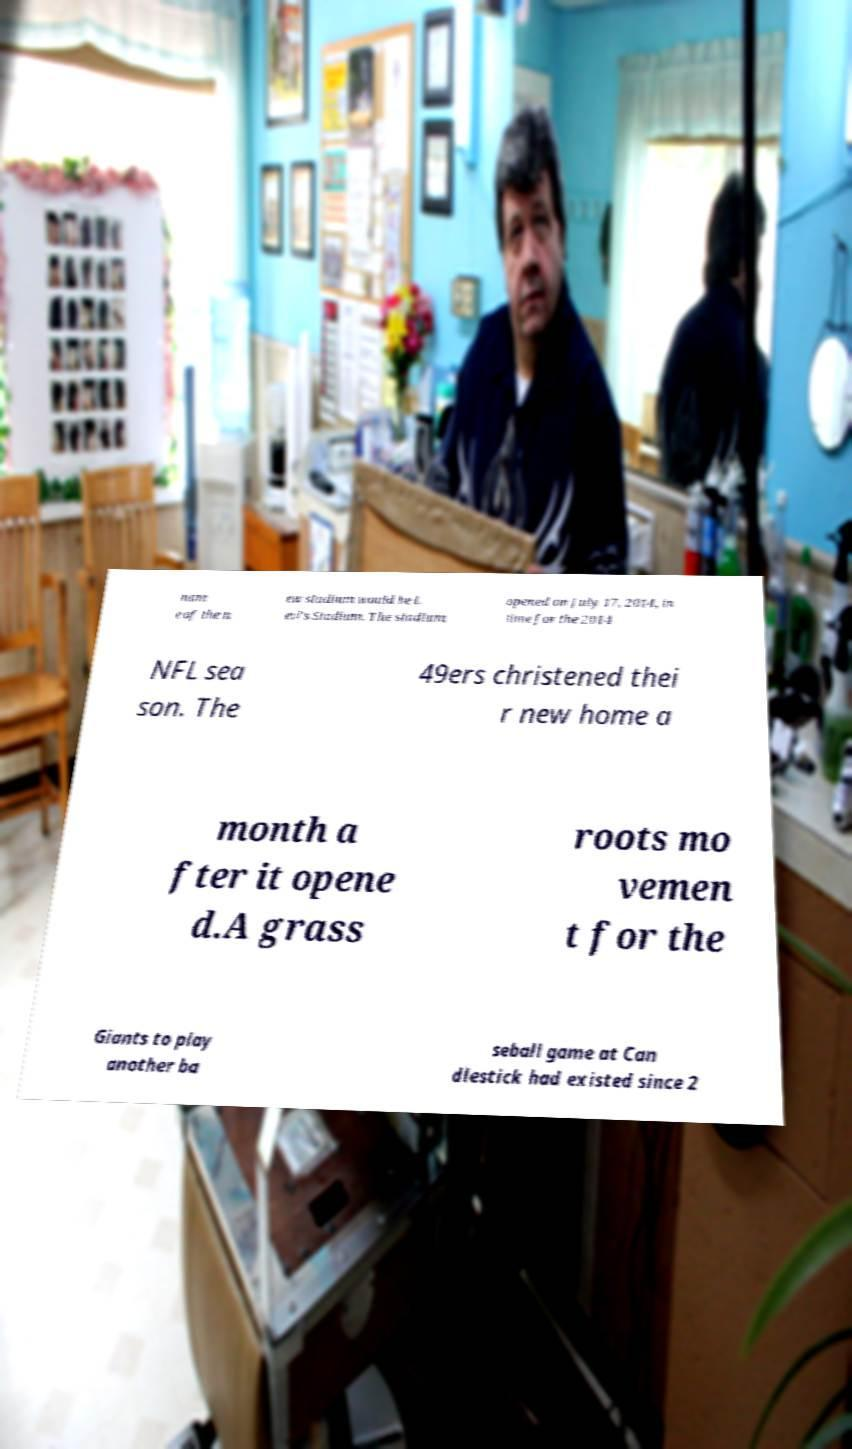Can you accurately transcribe the text from the provided image for me? nam e of the n ew stadium would be L evi's Stadium. The stadium opened on July 17, 2014, in time for the 2014 NFL sea son. The 49ers christened thei r new home a month a fter it opene d.A grass roots mo vemen t for the Giants to play another ba seball game at Can dlestick had existed since 2 